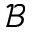Convert formula to latex. <formula><loc_0><loc_0><loc_500><loc_500>\mathcal { B }</formula> 